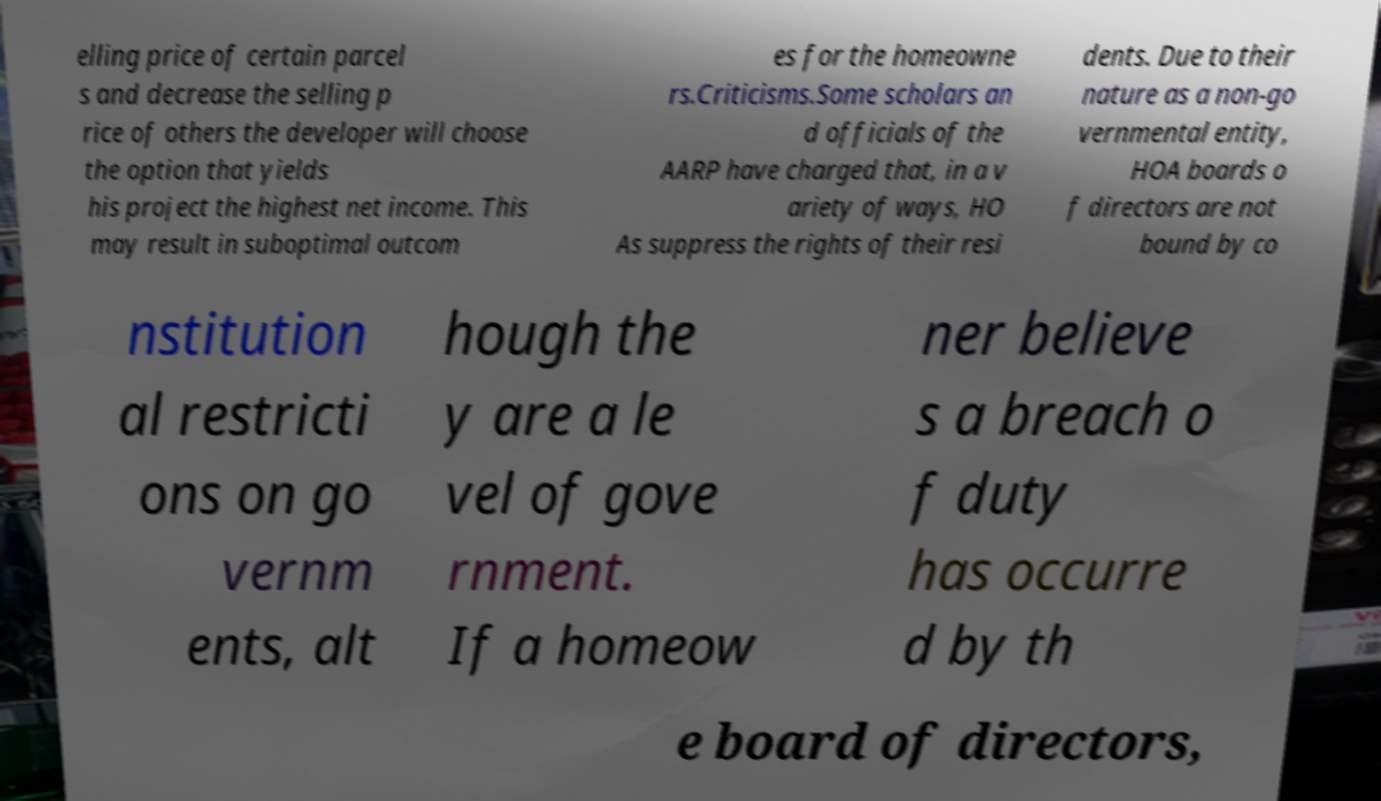Could you extract and type out the text from this image? elling price of certain parcel s and decrease the selling p rice of others the developer will choose the option that yields his project the highest net income. This may result in suboptimal outcom es for the homeowne rs.Criticisms.Some scholars an d officials of the AARP have charged that, in a v ariety of ways, HO As suppress the rights of their resi dents. Due to their nature as a non-go vernmental entity, HOA boards o f directors are not bound by co nstitution al restricti ons on go vernm ents, alt hough the y are a le vel of gove rnment. If a homeow ner believe s a breach o f duty has occurre d by th e board of directors, 